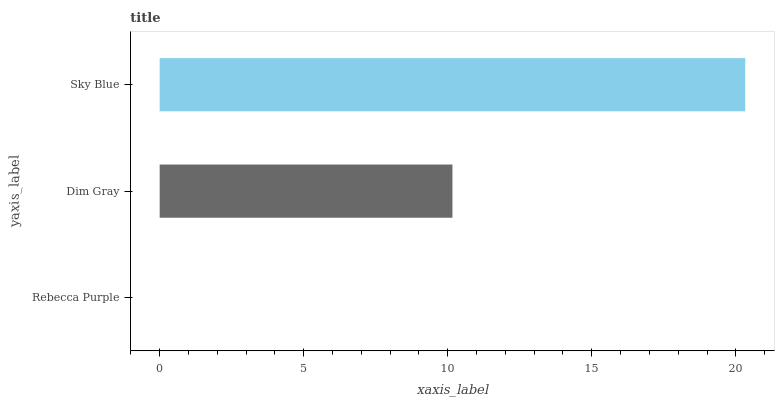Is Rebecca Purple the minimum?
Answer yes or no. Yes. Is Sky Blue the maximum?
Answer yes or no. Yes. Is Dim Gray the minimum?
Answer yes or no. No. Is Dim Gray the maximum?
Answer yes or no. No. Is Dim Gray greater than Rebecca Purple?
Answer yes or no. Yes. Is Rebecca Purple less than Dim Gray?
Answer yes or no. Yes. Is Rebecca Purple greater than Dim Gray?
Answer yes or no. No. Is Dim Gray less than Rebecca Purple?
Answer yes or no. No. Is Dim Gray the high median?
Answer yes or no. Yes. Is Dim Gray the low median?
Answer yes or no. Yes. Is Rebecca Purple the high median?
Answer yes or no. No. Is Sky Blue the low median?
Answer yes or no. No. 